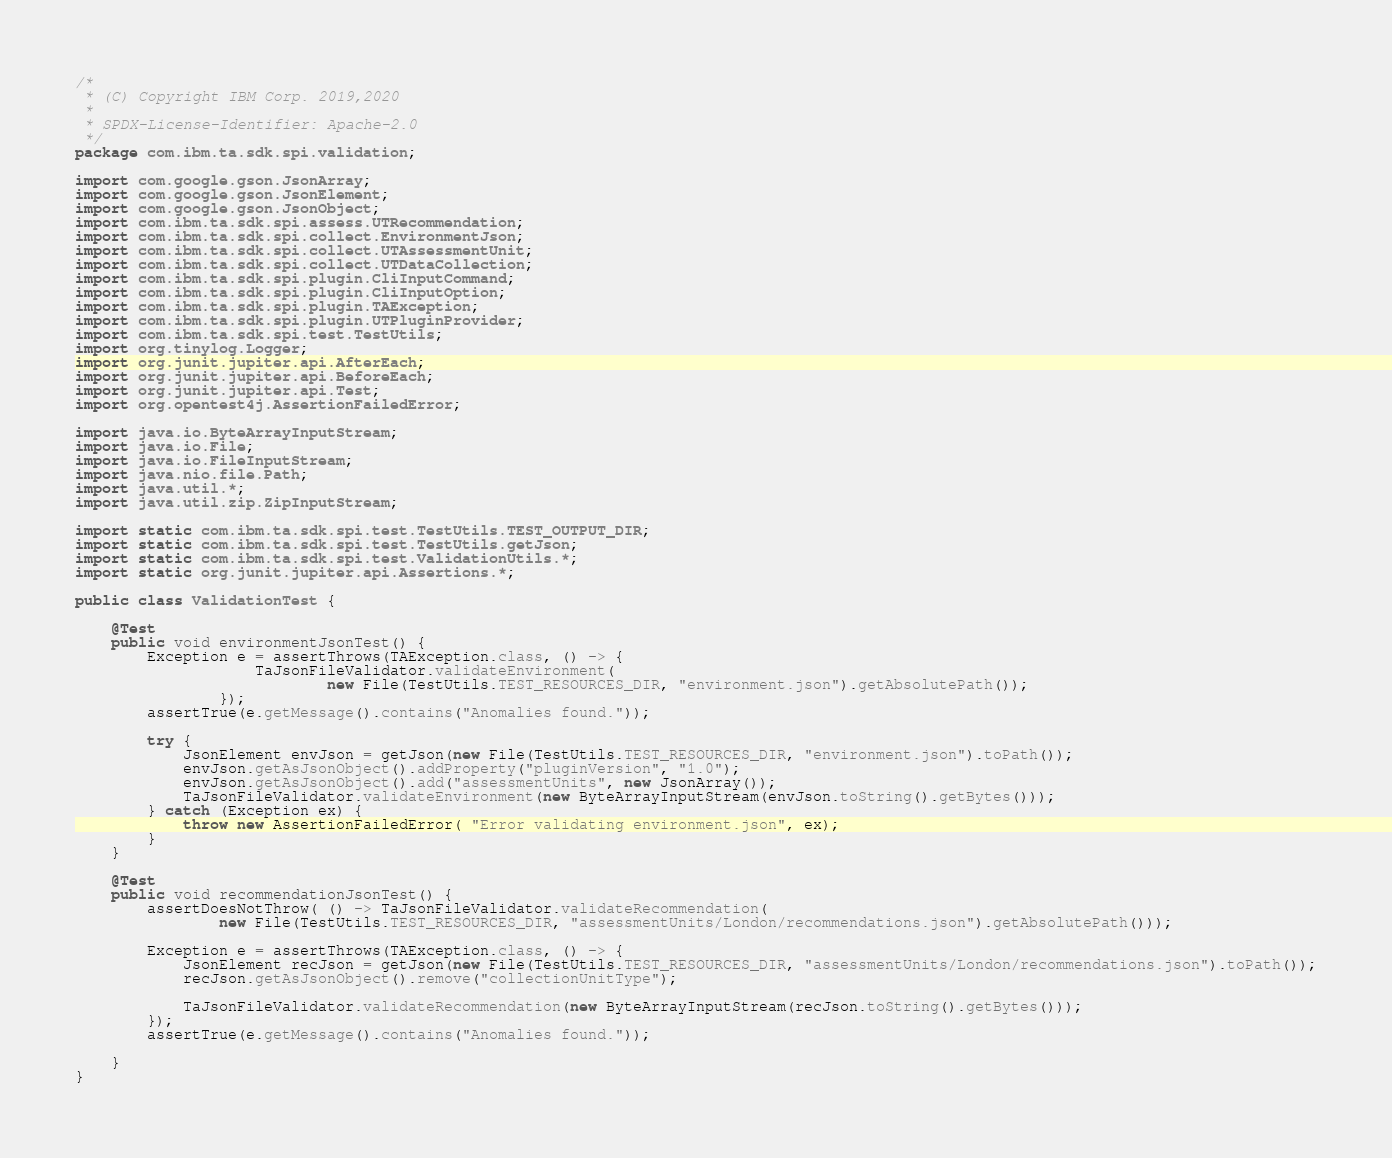Convert code to text. <code><loc_0><loc_0><loc_500><loc_500><_Java_>/*
 * (C) Copyright IBM Corp. 2019,2020
 *
 * SPDX-License-Identifier: Apache-2.0
 */
package com.ibm.ta.sdk.spi.validation;

import com.google.gson.JsonArray;
import com.google.gson.JsonElement;
import com.google.gson.JsonObject;
import com.ibm.ta.sdk.spi.assess.UTRecommendation;
import com.ibm.ta.sdk.spi.collect.EnvironmentJson;
import com.ibm.ta.sdk.spi.collect.UTAssessmentUnit;
import com.ibm.ta.sdk.spi.collect.UTDataCollection;
import com.ibm.ta.sdk.spi.plugin.CliInputCommand;
import com.ibm.ta.sdk.spi.plugin.CliInputOption;
import com.ibm.ta.sdk.spi.plugin.TAException;
import com.ibm.ta.sdk.spi.plugin.UTPluginProvider;
import com.ibm.ta.sdk.spi.test.TestUtils;
import org.tinylog.Logger;
import org.junit.jupiter.api.AfterEach;
import org.junit.jupiter.api.BeforeEach;
import org.junit.jupiter.api.Test;
import org.opentest4j.AssertionFailedError;

import java.io.ByteArrayInputStream;
import java.io.File;
import java.io.FileInputStream;
import java.nio.file.Path;
import java.util.*;
import java.util.zip.ZipInputStream;

import static com.ibm.ta.sdk.spi.test.TestUtils.TEST_OUTPUT_DIR;
import static com.ibm.ta.sdk.spi.test.TestUtils.getJson;
import static com.ibm.ta.sdk.spi.test.ValidationUtils.*;
import static org.junit.jupiter.api.Assertions.*;

public class ValidationTest {

    @Test
    public void environmentJsonTest() {
        Exception e = assertThrows(TAException.class, () -> {
                    TaJsonFileValidator.validateEnvironment(
                            new File(TestUtils.TEST_RESOURCES_DIR, "environment.json").getAbsolutePath());
                });
        assertTrue(e.getMessage().contains("Anomalies found."));

        try {
            JsonElement envJson = getJson(new File(TestUtils.TEST_RESOURCES_DIR, "environment.json").toPath());
            envJson.getAsJsonObject().addProperty("pluginVersion", "1.0");
            envJson.getAsJsonObject().add("assessmentUnits", new JsonArray());
            TaJsonFileValidator.validateEnvironment(new ByteArrayInputStream(envJson.toString().getBytes()));
        } catch (Exception ex) {
            throw new AssertionFailedError( "Error validating environment.json", ex);
        }
    }

    @Test
    public void recommendationJsonTest() {
        assertDoesNotThrow( () -> TaJsonFileValidator.validateRecommendation(
                new File(TestUtils.TEST_RESOURCES_DIR, "assessmentUnits/London/recommendations.json").getAbsolutePath()));

        Exception e = assertThrows(TAException.class, () -> {
            JsonElement recJson = getJson(new File(TestUtils.TEST_RESOURCES_DIR, "assessmentUnits/London/recommendations.json").toPath());
            recJson.getAsJsonObject().remove("collectionUnitType");

            TaJsonFileValidator.validateRecommendation(new ByteArrayInputStream(recJson.toString().getBytes()));
        });
        assertTrue(e.getMessage().contains("Anomalies found."));

    }
}
</code> 